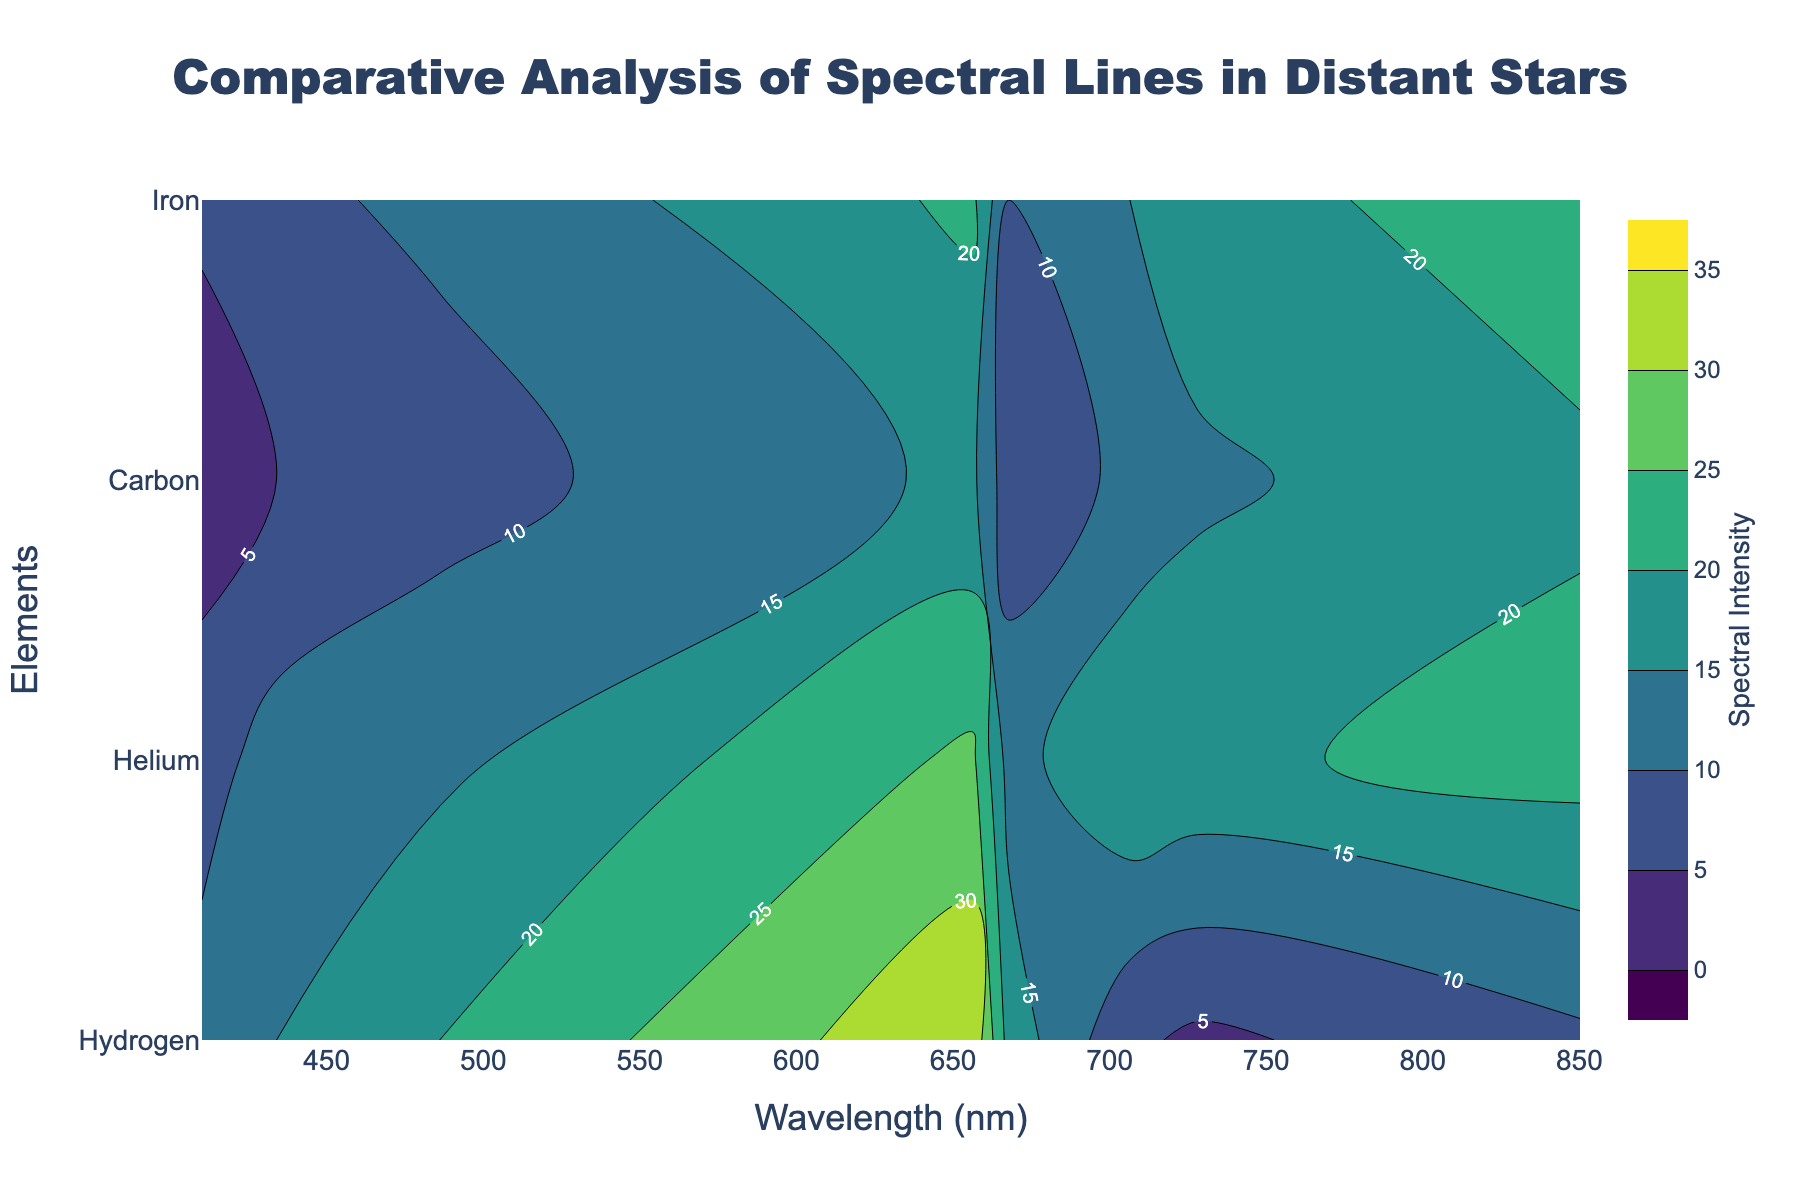What is the title of the plot? The title of the plot is typically displayed at the top of the figure. In this case, a quick glance will reveal the given text as the title.
Answer: "Comparative Analysis of Spectral Lines in Distant Stars" What elements are compared in this contour plot? The contour plot compares spectral lines for different elements, which are usually indicated on the y-axis. Here, the elements listed are Hydrogen, Helium, Carbon, and Iron.
Answer: Hydrogen, Helium, Carbon, Iron At which wavelength does Iron have the highest spectral intensity? To answer this, you need to look at the color gradients for the Iron row. The highest intensity will match the darkest shade. According to the data, the highest intensity for Iron is 23, which is at 850.2 nm.
Answer: 850.2 nm Which element has the lowest spectral intensity at 486.1 nm? This involves checking the spectral intensity values at the specific wavelength of 486.1 nm for all the elements. According to the data, Carbon's intensity is 8, which is the lowest at this wavelength.
Answer: Carbon Compare the spectral intensities of Hydrogen and Helium at 656.3 nm. Which one is higher, and by how much? Identify the values for Hydrogen and Helium at 656.3 nm. Hydrogen has an intensity of 34, and Helium has 26. The difference is calculated as 34 - 26 = 8.
Answer: Hydrogen, by 8 What is the range of the color bar indicating spectral intensity? The color bar range can be read directly from the plot. It usually shows the minimum and maximum values indicated by the start and end parameters in the contour setup. Here, it ranges from 0 to 35.
Answer: 0 to 35 Which two elements have almost similar spectral intensities at around 728.1 nm? Check the intensity values for all elements at 728.1 nm. Helium has an intensity of 19, and Carbon has an intensity of 14. These values are relatively close compared to other elements.
Answer: Helium and Carbon At what wavelength does Carbon's spectral intensity peak? By examining the intensity values of Carbon across all wavelengths, the highest spectral intensity for Carbon is 19, which occurs at 850.2 nm.
Answer: 850.2 nm How does the spectral intensity of Iron change as the wavelength increases from 410.2 nm to 850.2 nm? Look at the intensity values for Iron at all given wavelengths and observe the pattern. The intensities are 6, 9, 11, 21, 10, 15, 18, 23. Generally, there is an increasing trend with some fluctuations.
Answer: Increases with fluctuations What can be inferred about the overall spectral intensity trend of Hydrogen across the wavelengths? Review the intensity values for Hydrogen at all wavelengths. They are 12, 15, 20, 34, 18, 6, 4, 9. The values show an increase, peaking at 656.3 nm, followed by a decrease, indicating a non-linear trend with a prominent peak.
Answer: Non-linear with a peak at 656.3 nm 